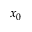<formula> <loc_0><loc_0><loc_500><loc_500>x _ { 0 }</formula> 